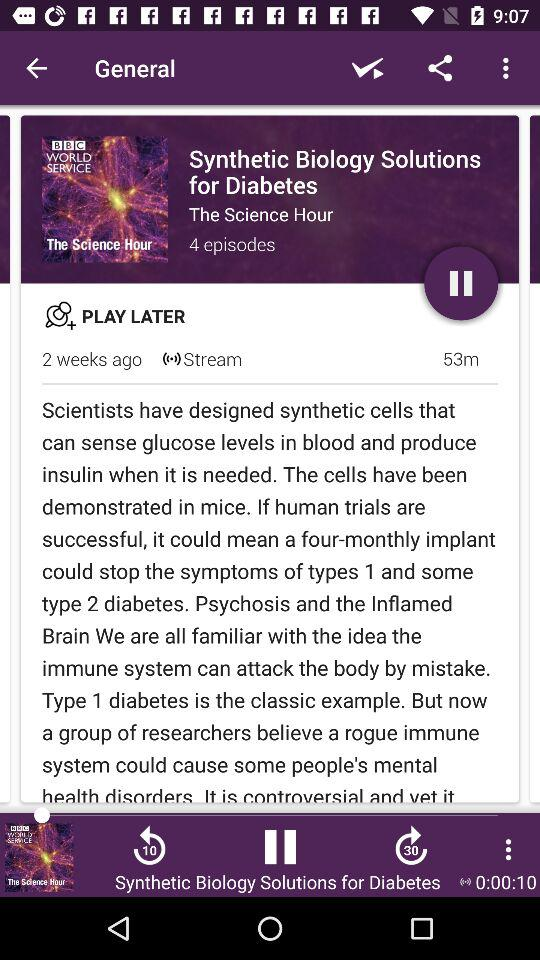How many episodes are there in the series? There are 4 episodes in the series. 